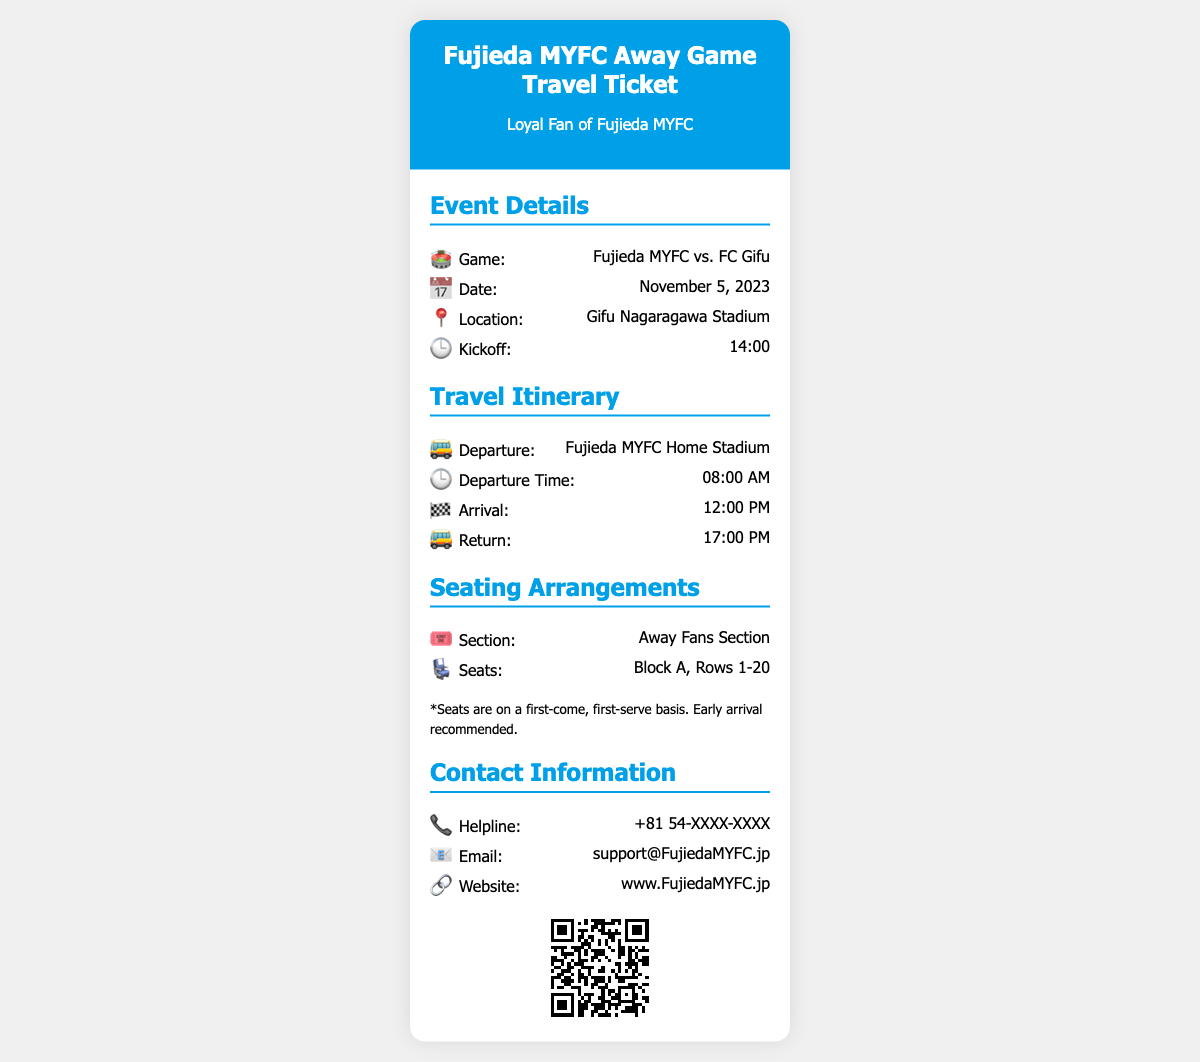What is the game for the away ticket? The game is identified in the event details section of the document.
Answer: Fujieda MYFC vs. FC Gifu What is the departure time for the bus? The departure time is specified in the travel itinerary section of the document.
Answer: 08:00 AM What date is the away game scheduled for? The date of the game is provided in the event details section.
Answer: November 5, 2023 What stadium will the game be played at? The location of the game is mentioned in the event details section.
Answer: Gifu Nagaragawa Stadium What section will the fans be seated in? The seating arrangements indicate the specific section for fans.
Answer: Away Fans Section At what time will the bus return? The return time is specified in the travel itinerary section of the document.
Answer: 17:00 PM What is the helpline number provided? The contact information includes a helpline number.
Answer: +81 54-XXXX-XXXX How many rows are included in Block A seating? The seating details specify the range of rows in Block A.
Answer: Rows 1-20 What is recommended for seating? The seating section provides additional advice for fans.
Answer: Early arrival recommended 